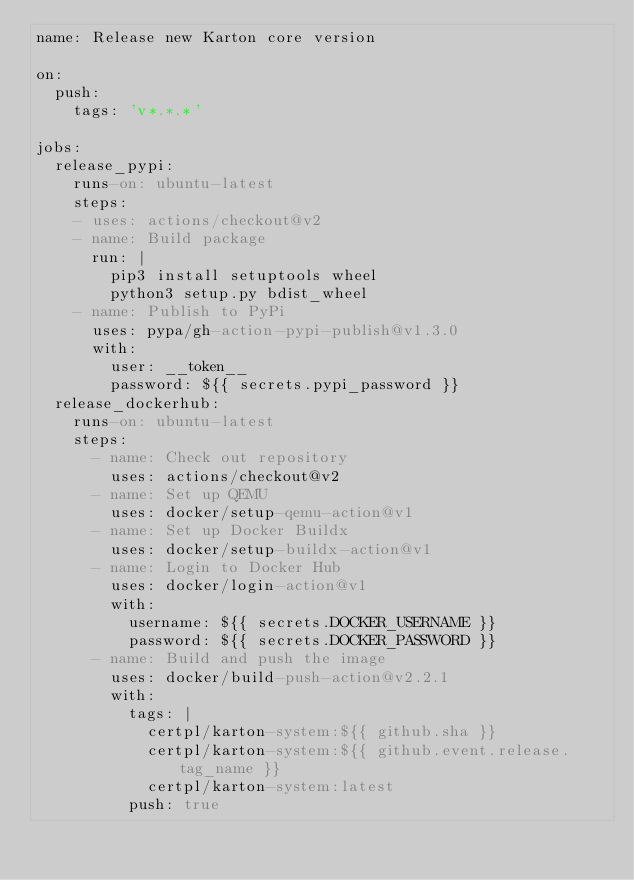<code> <loc_0><loc_0><loc_500><loc_500><_YAML_>name: Release new Karton core version

on:
  push:
    tags: 'v*.*.*'

jobs:
  release_pypi:
    runs-on: ubuntu-latest
    steps:
    - uses: actions/checkout@v2
    - name: Build package
      run: |
        pip3 install setuptools wheel
        python3 setup.py bdist_wheel
    - name: Publish to PyPi
      uses: pypa/gh-action-pypi-publish@v1.3.0
      with:
        user: __token__
        password: ${{ secrets.pypi_password }}
  release_dockerhub:
    runs-on: ubuntu-latest
    steps:
      - name: Check out repository
        uses: actions/checkout@v2
      - name: Set up QEMU
        uses: docker/setup-qemu-action@v1
      - name: Set up Docker Buildx
        uses: docker/setup-buildx-action@v1
      - name: Login to Docker Hub
        uses: docker/login-action@v1
        with:
          username: ${{ secrets.DOCKER_USERNAME }}
          password: ${{ secrets.DOCKER_PASSWORD }}
      - name: Build and push the image
        uses: docker/build-push-action@v2.2.1
        with:
          tags: |
            certpl/karton-system:${{ github.sha }}
            certpl/karton-system:${{ github.event.release.tag_name }}
            certpl/karton-system:latest
          push: true
</code> 